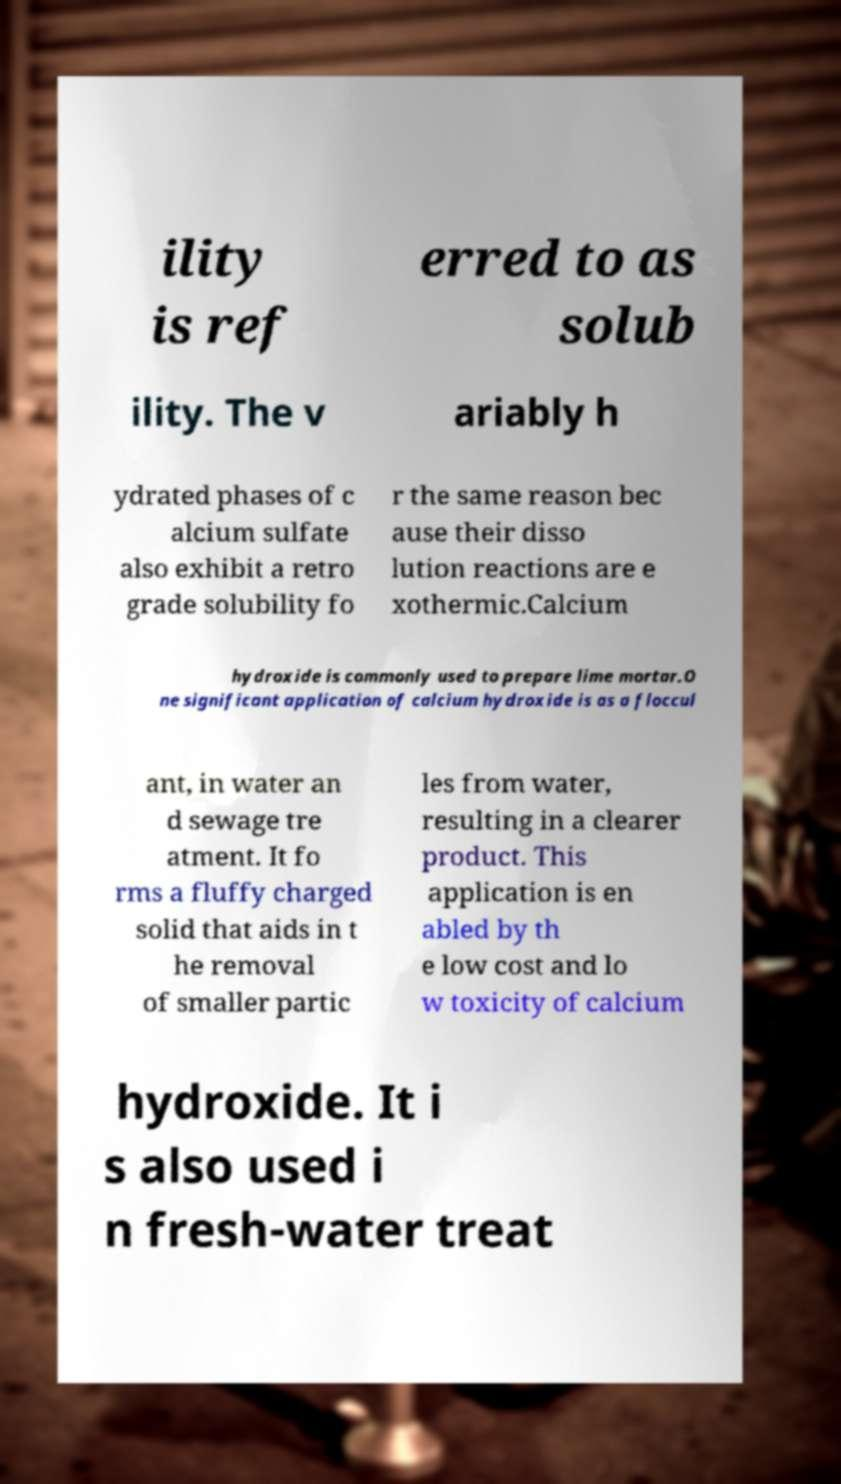There's text embedded in this image that I need extracted. Can you transcribe it verbatim? ility is ref erred to as solub ility. The v ariably h ydrated phases of c alcium sulfate also exhibit a retro grade solubility fo r the same reason bec ause their disso lution reactions are e xothermic.Calcium hydroxide is commonly used to prepare lime mortar.O ne significant application of calcium hydroxide is as a floccul ant, in water an d sewage tre atment. It fo rms a fluffy charged solid that aids in t he removal of smaller partic les from water, resulting in a clearer product. This application is en abled by th e low cost and lo w toxicity of calcium hydroxide. It i s also used i n fresh-water treat 